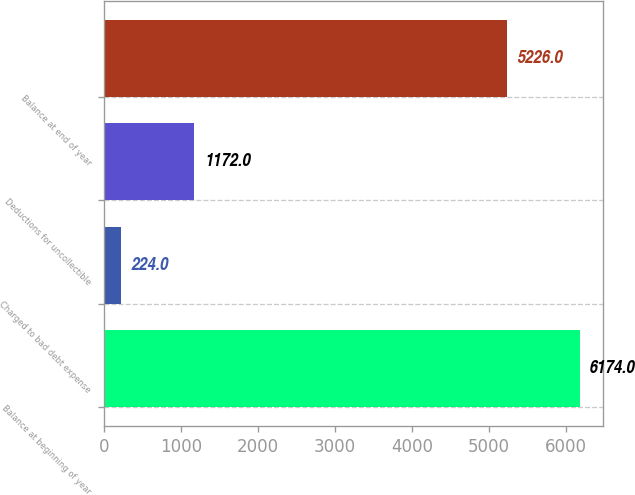Convert chart. <chart><loc_0><loc_0><loc_500><loc_500><bar_chart><fcel>Balance at beginning of year<fcel>Charged to bad debt expense<fcel>Deductions for uncollectible<fcel>Balance at end of year<nl><fcel>6174<fcel>224<fcel>1172<fcel>5226<nl></chart> 